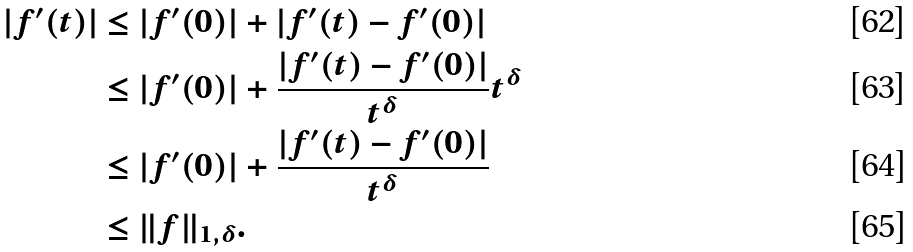Convert formula to latex. <formula><loc_0><loc_0><loc_500><loc_500>| f ^ { \prime } ( t ) | & \leq | f ^ { \prime } ( 0 ) | + | f ^ { \prime } ( t ) - f ^ { \prime } ( 0 ) | \\ & \leq | f ^ { \prime } ( 0 ) | + \frac { | f ^ { \prime } ( t ) - f ^ { \prime } ( 0 ) | } { t ^ { \delta } } t ^ { \delta } \\ & \leq | f ^ { \prime } ( 0 ) | + \frac { | f ^ { \prime } ( t ) - f ^ { \prime } ( 0 ) | } { t ^ { \delta } } \\ & \leq \| f \| _ { 1 , \delta } .</formula> 